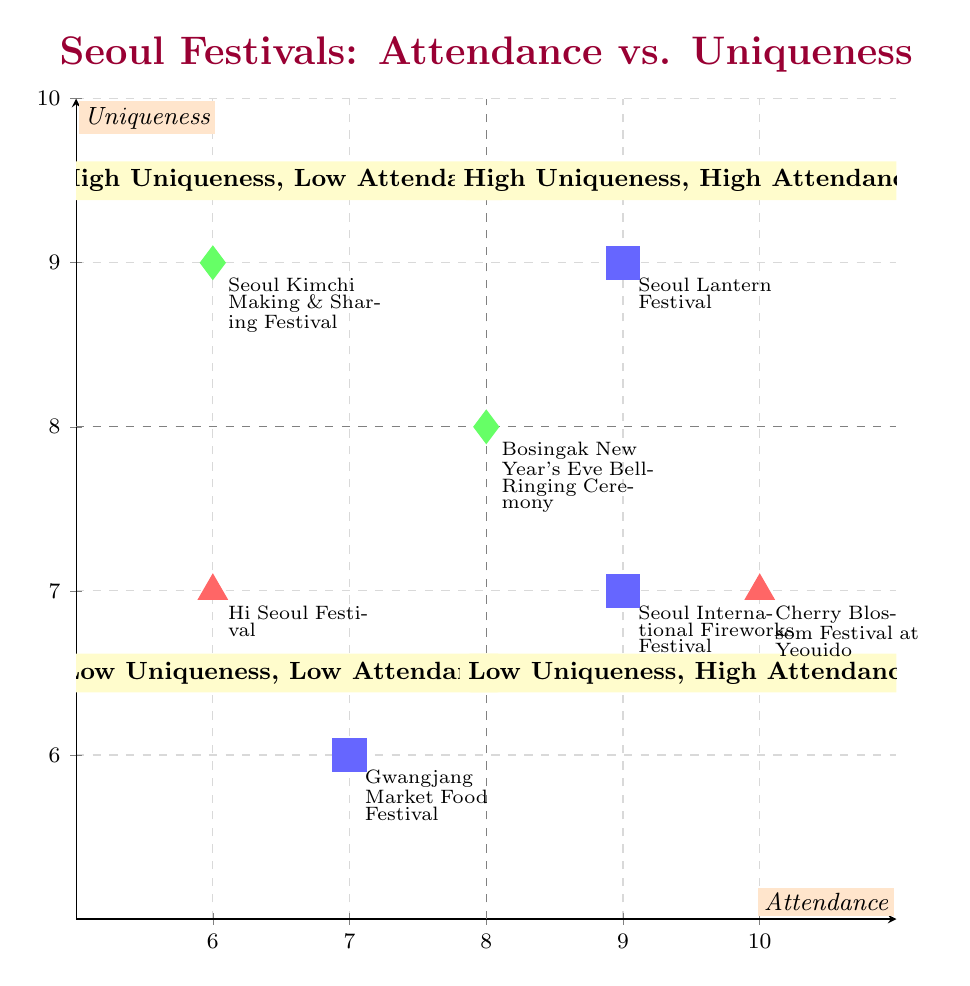What is the attendance of the Cherry Blossom Festival at Yeouido? The attendance value for the Cherry Blossom Festival at Yeouido is shown along the x-axis of the diagram. It is marked at 10.
Answer: 10 Which festival has the highest uniqueness score? By examining the y-axis values of each festival's uniqueness, the Seoul Lantern Festival, which is at the coordinates (9,9), has the highest score of 9.
Answer: Seoul Lantern Festival How many festivals fall in the "High Uniqueness, Low Attendance" quadrant? In this quadrant, unique festival entries with lower attendance, specifically between the intersection of 8 attendance and 9 uniqueness, indicate that only the Seoul Kimchi Making & Sharing Festival fits this description, hence counting as one festival.
Answer: 1 What is the uniqueness score of the Gwangjang Market Food Festival? The Gwangjang Market Food Festival is plotted on the graph at coordinates (7,6). By checking the y-axis, the uniqueness score corresponds to the value 6.
Answer: 6 Which festival has both high uniqueness and high attendance? To find festivals that have both high uniqueness (above 8) and attendance (above 8), we analyze the points in the quadrant. The Seoul Lantern Festival at (9,9) is the only one that meets both criteria.
Answer: Seoul Lantern Festival What is the attendance of the Seoul International Fireworks Festival? Looking at the x-axis where the Seoul International Fireworks Festival is plotted at (9,7), we see that its attendance score is 9.
Answer: 9 Which two festivals have the same uniqueness score of 7? By evaluating the points plotted between the axes, we find that the Cherry Blossom Festival at Yeouido and the Seoul International Fireworks Festival both share a uniqueness score of 7.
Answer: Cherry Blossom Festival at Yeouido, Seoul International Fireworks Festival How many festivals have low uniqueness and high attendance? Low uniqueness is defined as locations below 7 on the y-axis, with high attendance being above 8 on the x-axis. In this chart, we find only one festival, the Seoul International Fireworks Festival, which falls under high attendance while below an uniqueness score of 8.
Answer: 1 What is the score for attendance and uniqueness for the Hi Seoul Festival? The Hi Seoul Festival is plotted at the coordinates (6,7) on the graph. Therefore, its attendance is 6 and its uniqueness score is 7 according to the respective axes.
Answer: Attendance: 6, Uniqueness: 7 